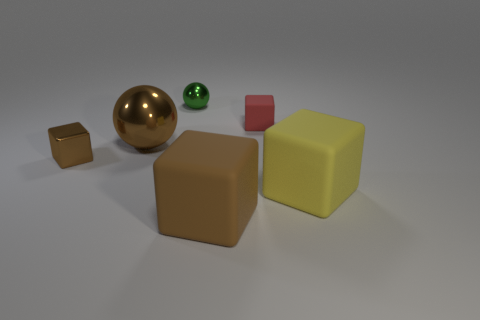There is a cube that is on the left side of the big brown object in front of the big object behind the large yellow thing; what size is it?
Ensure brevity in your answer.  Small. There is a small block that is to the right of the brown metallic cube; what is its color?
Offer a terse response. Red. Is the number of brown cubes on the left side of the large brown matte cube greater than the number of tiny purple metallic blocks?
Your answer should be very brief. Yes. Do the tiny object that is on the left side of the green metal sphere and the green shiny object have the same shape?
Offer a very short reply. No. How many brown objects are balls or rubber balls?
Your answer should be compact. 1. Is the number of tiny things greater than the number of objects?
Give a very brief answer. No. The ball that is the same size as the red object is what color?
Provide a short and direct response. Green. How many cubes are tiny brown objects or rubber things?
Give a very brief answer. 4. Is the shape of the large brown shiny object the same as the brown object that is on the right side of the green shiny ball?
Your answer should be compact. No. What number of objects are the same size as the red rubber cube?
Ensure brevity in your answer.  2. 